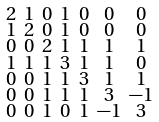<formula> <loc_0><loc_0><loc_500><loc_500>\begin{smallmatrix} 2 & 1 & 0 & 1 & 0 & 0 & 0 \\ 1 & 2 & 0 & 1 & 0 & 0 & 0 \\ 0 & 0 & 2 & 1 & 1 & 1 & 1 \\ 1 & 1 & 1 & 3 & 1 & 1 & 0 \\ 0 & 0 & 1 & 1 & 3 & 1 & 1 \\ 0 & 0 & 1 & 1 & 1 & 3 & - 1 \\ 0 & 0 & 1 & 0 & 1 & - 1 & 3 \end{smallmatrix}</formula> 